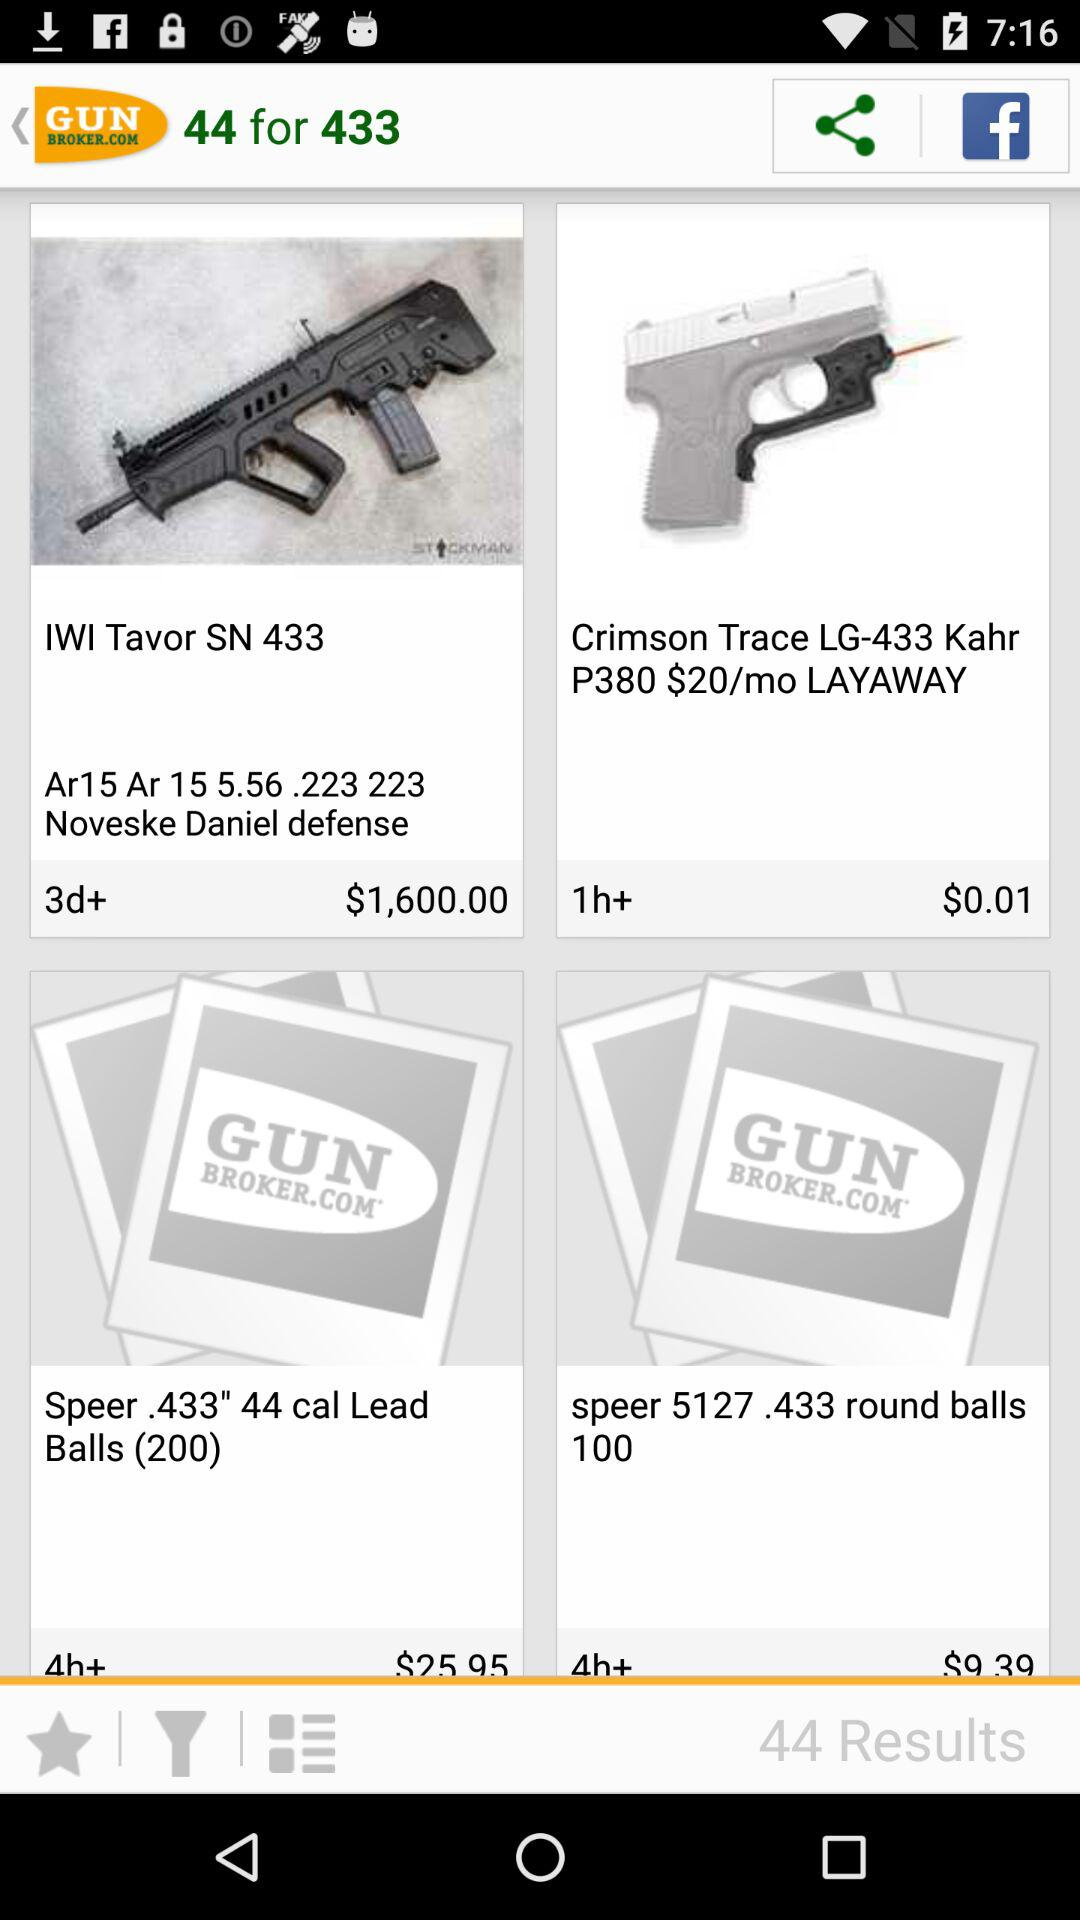What application can be used to share? The application is "Facebook". 